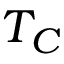Convert formula to latex. <formula><loc_0><loc_0><loc_500><loc_500>T _ { C }</formula> 